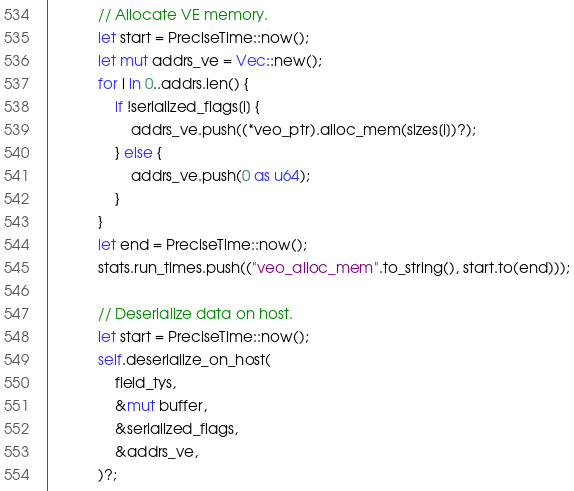Convert code to text. <code><loc_0><loc_0><loc_500><loc_500><_Rust_>            // Allocate VE memory.
            let start = PreciseTime::now();
            let mut addrs_ve = Vec::new();
            for i in 0..addrs.len() {
                if !serialized_flags[i] {
                    addrs_ve.push((*veo_ptr).alloc_mem(sizes[i])?);
                } else {
                    addrs_ve.push(0 as u64);
                }
            }
            let end = PreciseTime::now();
            stats.run_times.push(("veo_alloc_mem".to_string(), start.to(end)));

            // Deserialize data on host.
            let start = PreciseTime::now();
            self.deserialize_on_host(
                field_tys,
                &mut buffer,
                &serialized_flags,
                &addrs_ve,
            )?;</code> 